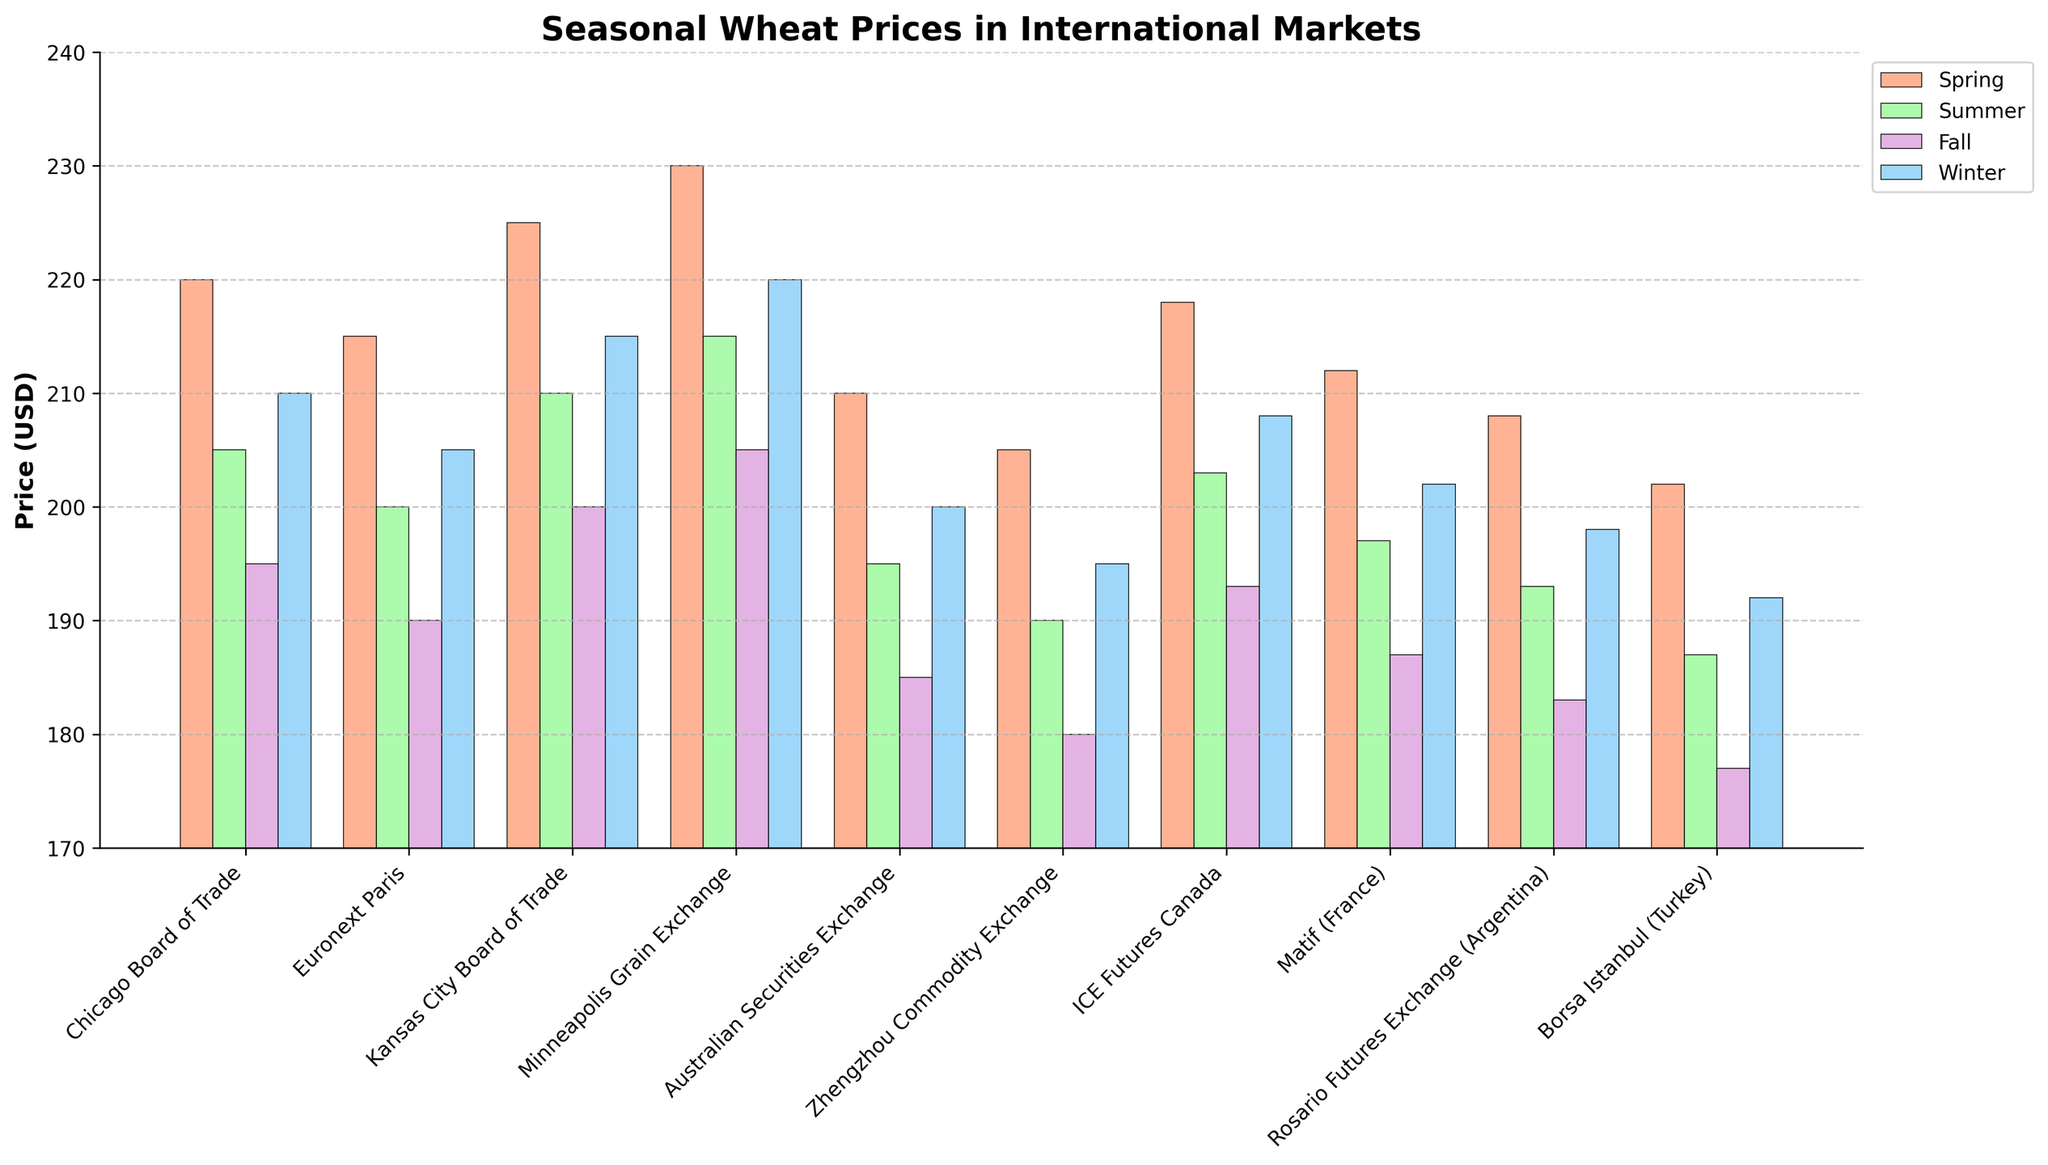What is the average price of wheat in the Spring season across all markets? First, list out the Spring prices for all markets: 220, 215, 225, 230, 210, 205, 218, 212, 208, 202. Sum these values: 220 + 215 + 225 + 230 + 210 + 205 + 218 + 212 + 208 + 202 = 2145. Then, divide by the number of markets (10). 2145 / 10 = 214.5
Answer: 214.5 Which market has the lowest wheat price in the Fall season? Check the Fall prices for each market: 195, 190, 200, 205, 185, 180, 193, 187, 183, 177. The lowest value is 177. Identify the corresponding market, which is Borsa Istanbul (Turkey).
Answer: Borsa Istanbul (Turkey) How much higher is the Spring price compared to the Summer price for the Minneapolis Grain Exchange? Find the Spring price (230) and Summer price (215) for the Minneapolis Grain Exchange, then calculate the difference: 230 - 215 = 15.
Answer: 15 Which season shows the highest price in the ICE Futures Canada market? Look at the prices for ICE Futures Canada: Spring (218), Summer (203), Fall (193), and Winter (208). The highest value is 218, which is in Spring.
Answer: Spring What is the average price of wheat in the Winter season across all markets? List out the Winter prices for all markets: 210, 205, 215, 220, 200, 195, 208, 202, 198, 192. Sum these values: 210 + 205 + 215 + 220 + 200 + 195 + 208 + 202 + 198 + 192 = 2045. Then, divide by the number of markets (10). 2045 / 10 = 204.5
Answer: 204.5 Which market has the highest price in the Fall season? Check the Fall prices for each market: 195, 190, 200, 205, 185, 180, 193, 187, 183, 177. The highest value is 205, which corresponds to the Minneapolis Grain Exchange.
Answer: Minneapolis Grain Exchange Compare the Winter prices of the Australian Securities Exchange and Zhengzhou Commodity Exchange. Which is higher? Look at the Winter prices for Australian Securities Exchange (200) and Zhengzhou Commodity Exchange (195). The Australian Securities Exchange has the higher price (200 > 195).
Answer: Australian Securities Exchange What is the range of prices (difference between highest and lowest) for the Rosario Futures Exchange across all seasons? Identify the prices for Rosario Futures Exchange: Spring (208), Summer (193), Fall (183), Winter (198). Calculate the range: the highest price is 208 and the lowest is 183. The range is 208 - 183 = 25.
Answer: 25 Which market shows the smallest difference between Spring and Winter prices? Calculate the differences between Spring and Winter prices for each market: Chicago Board of Trade (220 - 210 = 10), Euronext Paris (215 - 205 = 10), Kansas City Board of Trade (225 - 215 = 10), Minneapolis Grain Exchange (230 - 220 = 10), Australian Securities Exchange (210 - 200 = 10), Zhengzhou Commodity Exchange (205 - 195 = 10), ICE Futures Canada (218 - 208 = 10), Matif (France) (212 - 202 = 10), Rosario Futures Exchange (208 - 198 = 10), Borsa Istanbul (Turkey) (202 - 192 = 10). All markets have the same difference of 10.
Answer: All markets Which season generally has the lowest wheat prices across all markets? Compare the average prices for each season. Sum the prices:
- Spring: 2145
- Summer: 2003
- Fall: 1918
- Winter: 2045. The lowest total is for Fall.
Answer: Fall 